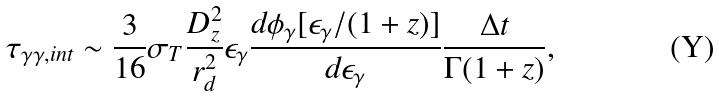Convert formula to latex. <formula><loc_0><loc_0><loc_500><loc_500>\tau _ { \gamma \gamma , i n t } \sim \frac { 3 } { 1 6 } \sigma _ { T } \frac { D _ { z } ^ { 2 } } { r _ { d } ^ { 2 } } \epsilon _ { \gamma } \frac { d \phi _ { \gamma } [ \epsilon _ { \gamma } / ( 1 + z ) ] } { d \epsilon _ { \gamma } } \frac { \Delta t } { \Gamma ( 1 + z ) } ,</formula> 